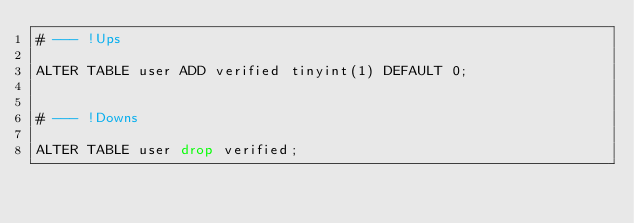<code> <loc_0><loc_0><loc_500><loc_500><_SQL_># --- !Ups

ALTER TABLE user ADD verified tinyint(1) DEFAULT 0;


# --- !Downs

ALTER TABLE user drop verified;
</code> 